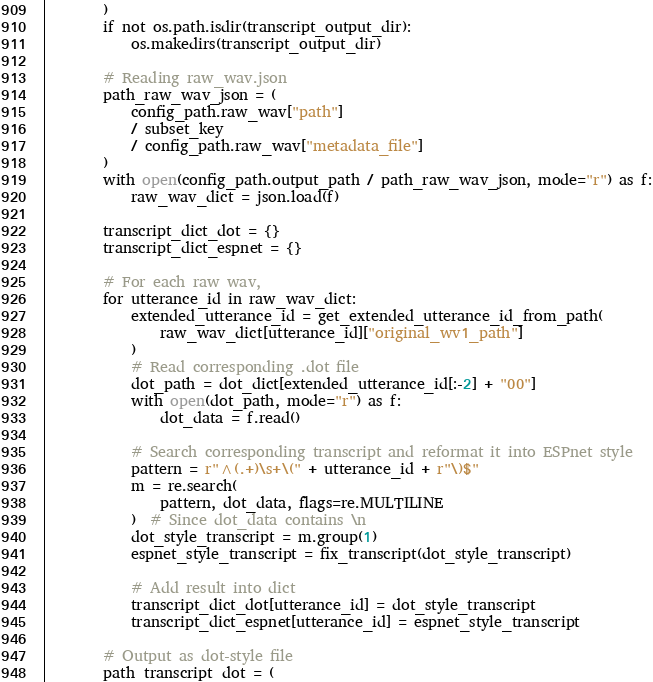Convert code to text. <code><loc_0><loc_0><loc_500><loc_500><_Python_>        )
        if not os.path.isdir(transcript_output_dir):
            os.makedirs(transcript_output_dir)

        # Reading raw_wav.json
        path_raw_wav_json = (
            config_path.raw_wav["path"]
            / subset_key
            / config_path.raw_wav["metadata_file"]
        )
        with open(config_path.output_path / path_raw_wav_json, mode="r") as f:
            raw_wav_dict = json.load(f)

        transcript_dict_dot = {}
        transcript_dict_espnet = {}

        # For each raw wav,
        for utterance_id in raw_wav_dict:
            extended_utterance_id = get_extended_utterance_id_from_path(
                raw_wav_dict[utterance_id]["original_wv1_path"]
            )
            # Read corresponding .dot file
            dot_path = dot_dict[extended_utterance_id[:-2] + "00"]
            with open(dot_path, mode="r") as f:
                dot_data = f.read()

            # Search corresponding transcript and reformat it into ESPnet style
            pattern = r"^(.+)\s+\(" + utterance_id + r"\)$"
            m = re.search(
                pattern, dot_data, flags=re.MULTILINE
            )  # Since dot_data contains \n
            dot_style_transcript = m.group(1)
            espnet_style_transcript = fix_transcript(dot_style_transcript)

            # Add result into dict
            transcript_dict_dot[utterance_id] = dot_style_transcript
            transcript_dict_espnet[utterance_id] = espnet_style_transcript

        # Output as dot-style file
        path_transcript_dot = (</code> 